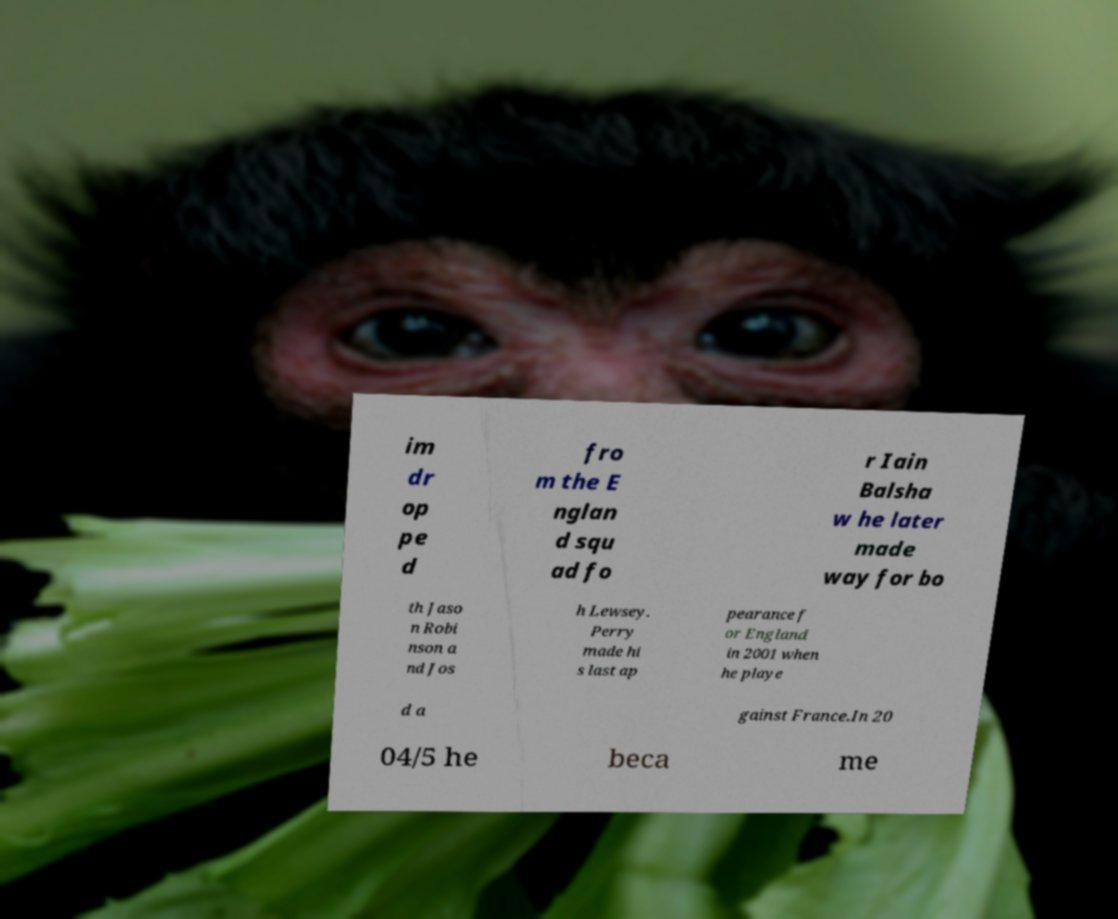Please read and relay the text visible in this image. What does it say? im dr op pe d fro m the E nglan d squ ad fo r Iain Balsha w he later made way for bo th Jaso n Robi nson a nd Jos h Lewsey. Perry made hi s last ap pearance f or England in 2001 when he playe d a gainst France.In 20 04/5 he beca me 